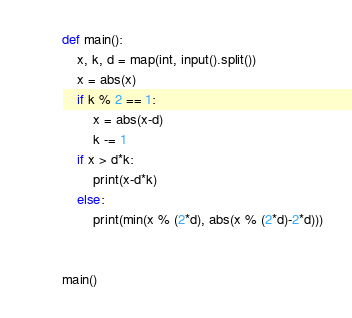Convert code to text. <code><loc_0><loc_0><loc_500><loc_500><_Python_>def main():
    x, k, d = map(int, input().split())
    x = abs(x)
    if k % 2 == 1:
        x = abs(x-d)
        k -= 1
    if x > d*k:
        print(x-d*k)
    else:
        print(min(x % (2*d), abs(x % (2*d)-2*d)))


main()
</code> 